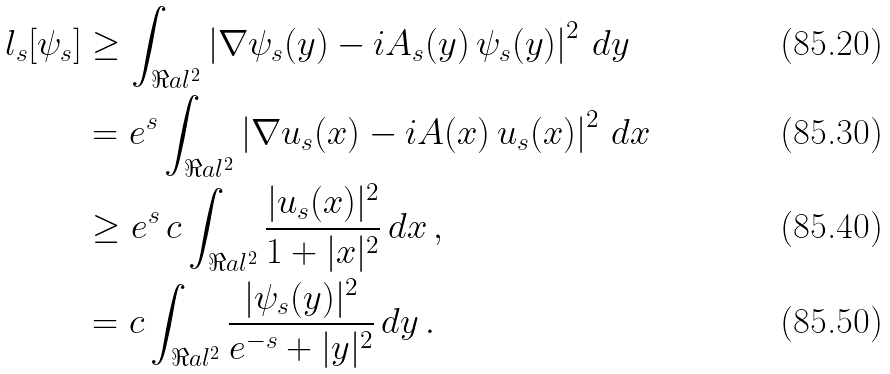Convert formula to latex. <formula><loc_0><loc_0><loc_500><loc_500>l _ { s } [ \psi _ { s } ] & \geq \int _ { \Re a l ^ { 2 } } \left | \nabla \psi _ { s } ( y ) - i A _ { s } ( y ) \, \psi _ { s } ( y ) \right | ^ { 2 } \, d y \\ & = e ^ { s } \int _ { \Re a l ^ { 2 } } \left | \nabla u _ { s } ( x ) - i A ( x ) \, u _ { s } ( x ) \right | ^ { 2 } \, d x \\ & \geq e ^ { s } \, c \int _ { \Re a l ^ { 2 } } \frac { | u _ { s } ( x ) | ^ { 2 } } { 1 + | x | ^ { 2 } } \, d x \, , \\ & = c \int _ { \Re a l ^ { 2 } } \frac { | \psi _ { s } ( y ) | ^ { 2 } } { e ^ { - s } + | y | ^ { 2 } } \, d y \, .</formula> 